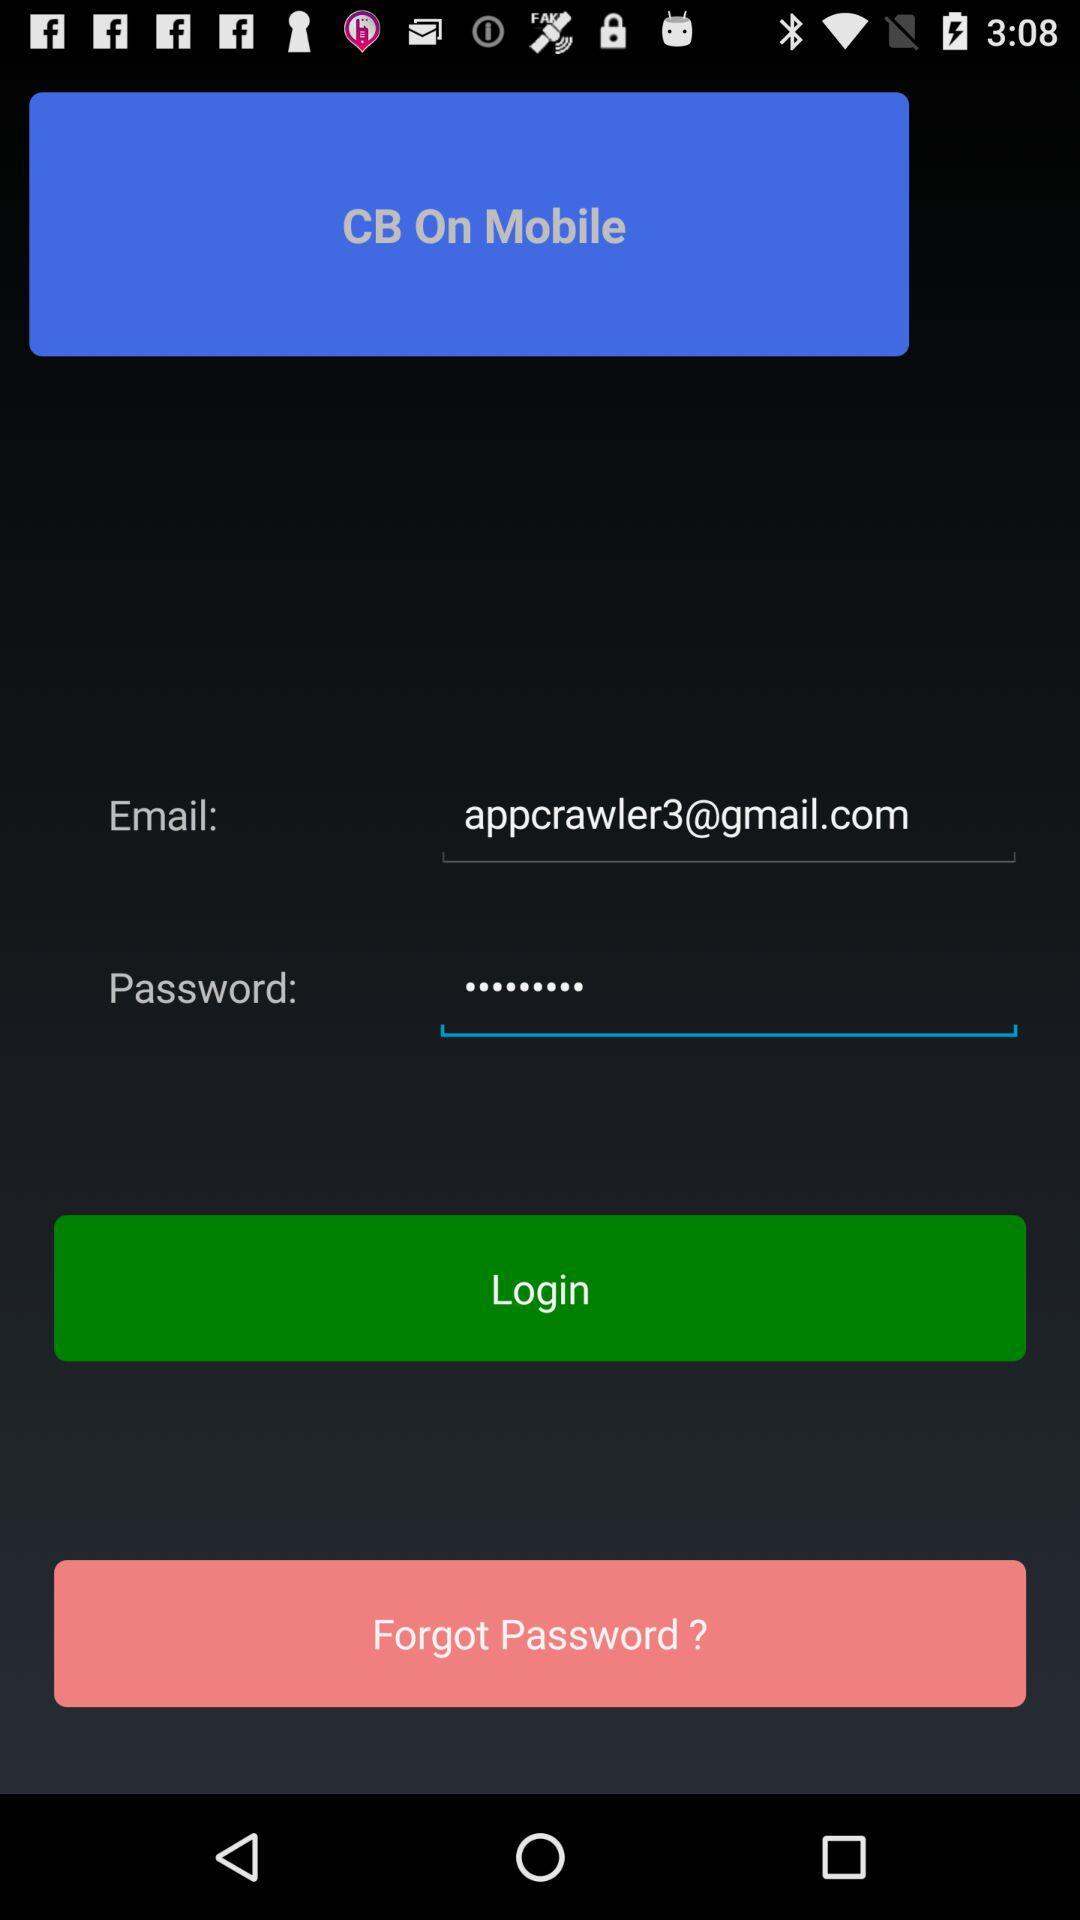What is the email address? The email address is appcrawler3@gmail.com. 